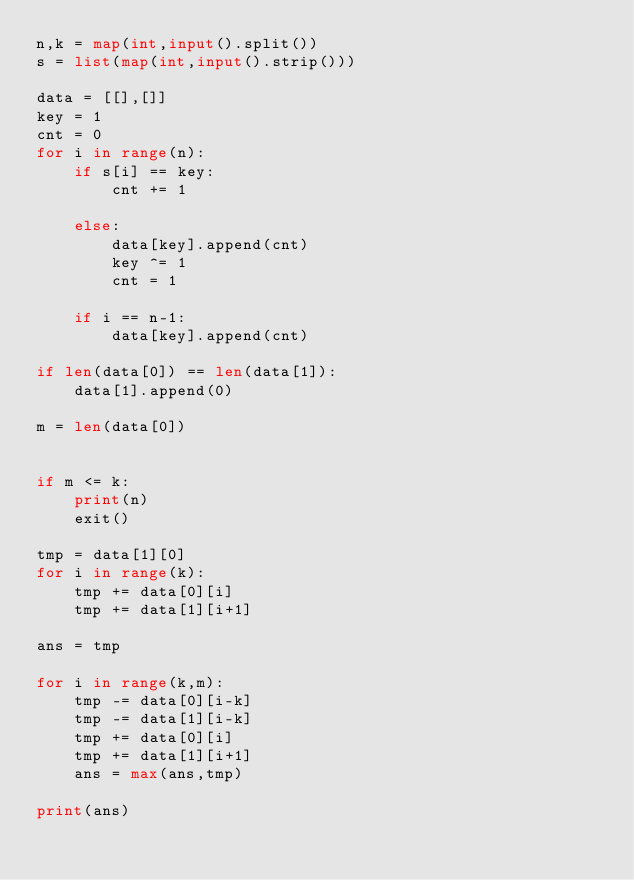Convert code to text. <code><loc_0><loc_0><loc_500><loc_500><_Python_>n,k = map(int,input().split())
s = list(map(int,input().strip()))

data = [[],[]]
key = 1
cnt = 0
for i in range(n):
    if s[i] == key:
        cnt += 1
    
    else:
        data[key].append(cnt)
        key ^= 1
        cnt = 1
        
    if i == n-1:
        data[key].append(cnt)
    
if len(data[0]) == len(data[1]):
    data[1].append(0)

m = len(data[0])


if m <= k:
    print(n)
    exit()

tmp = data[1][0]
for i in range(k):
    tmp += data[0][i]
    tmp += data[1][i+1]

ans = tmp

for i in range(k,m):
    tmp -= data[0][i-k]
    tmp -= data[1][i-k]
    tmp += data[0][i]
    tmp += data[1][i+1]
    ans = max(ans,tmp)

print(ans)</code> 